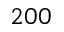Convert formula to latex. <formula><loc_0><loc_0><loc_500><loc_500>2 0 0</formula> 